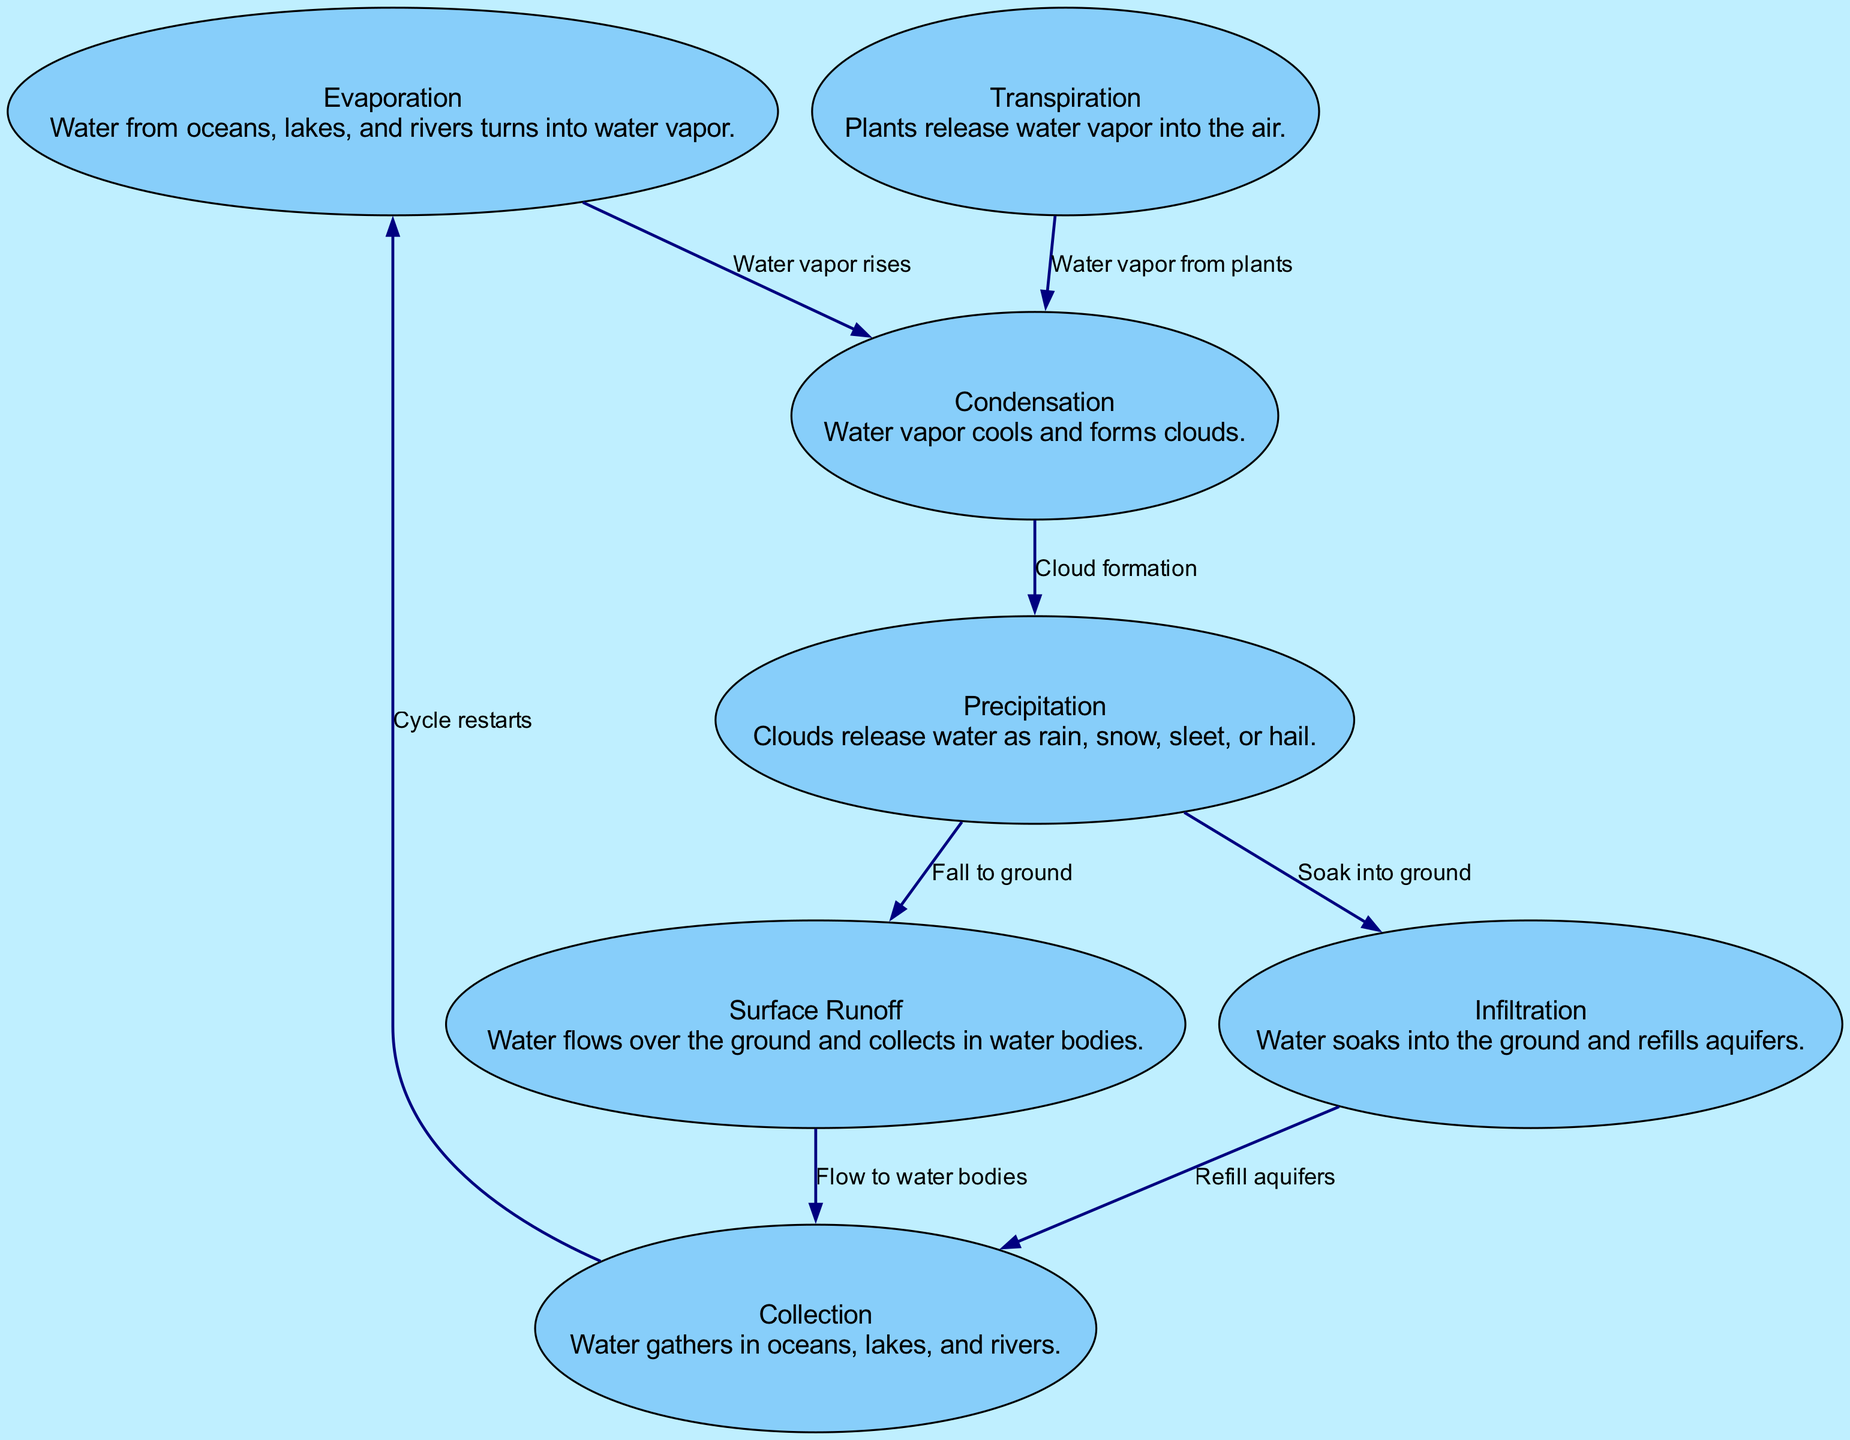What is the first stage of the water cycle? The water cycle starts with "Evaporation," where water from oceans, lakes, and rivers turns into water vapor.
Answer: Evaporation How many nodes are in the water cycle diagram? Counting through the diagram, there are a total of 7 distinct nodes representing different stages of the water cycle.
Answer: 7 What process follows condensation in the water cycle? After condensation, the next process is "Precipitation," where clouds release water as rain, snow, sleet, or hail.
Answer: Precipitation Which process describes water soaking into the ground? The process described as water soaking into the ground is known as "Infiltration."
Answer: Infiltration What is the relationship between precipitation and surface runoff? The relationship is that precipitation leads to surface runoff when water falls to the ground and flows over the landscape.
Answer: Fall to ground How does transpiration affect condensation? Transpiration introduces water vapor from plants into the air, which contributes to the condensation process as the vapor cools and forms clouds.
Answer: Water vapor from plants Which node does collection lead back to in the water cycle? The "Collection" node leads back to the "Evaporation" node, indicating the cycle restarts from there.
Answer: Evaporation What label describes the flow from surface runoff to collection? The label for this flow is "Flow to water bodies," showing the transition of water into larger bodies of water.
Answer: Flow to water bodies What happens after clouds form according to the diagram? After clouds form, the next event is "Precipitation," where the clouds release the water they contain.
Answer: Precipitation How is water collected back into larger bodies after precipitation? After precipitation, the water is either absorbed into the ground (infiltration) or flows over the surface (surface runoff) before collecting into larger bodies of water.
Answer: Surface Runoff 